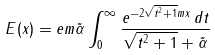<formula> <loc_0><loc_0><loc_500><loc_500>E ( x ) = e m \tilde { \alpha } \int _ { 0 } ^ { \infty } \frac { e ^ { - 2 \sqrt { t ^ { 2 } + 1 } m x } \, d t } { \sqrt { t ^ { 2 } + 1 } + \tilde { \alpha } }</formula> 